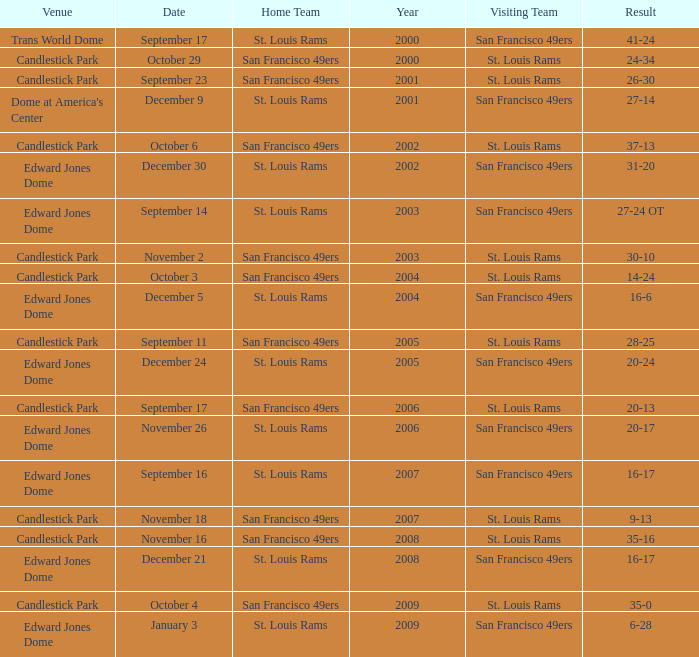What was the Venue on November 26? Edward Jones Dome. 